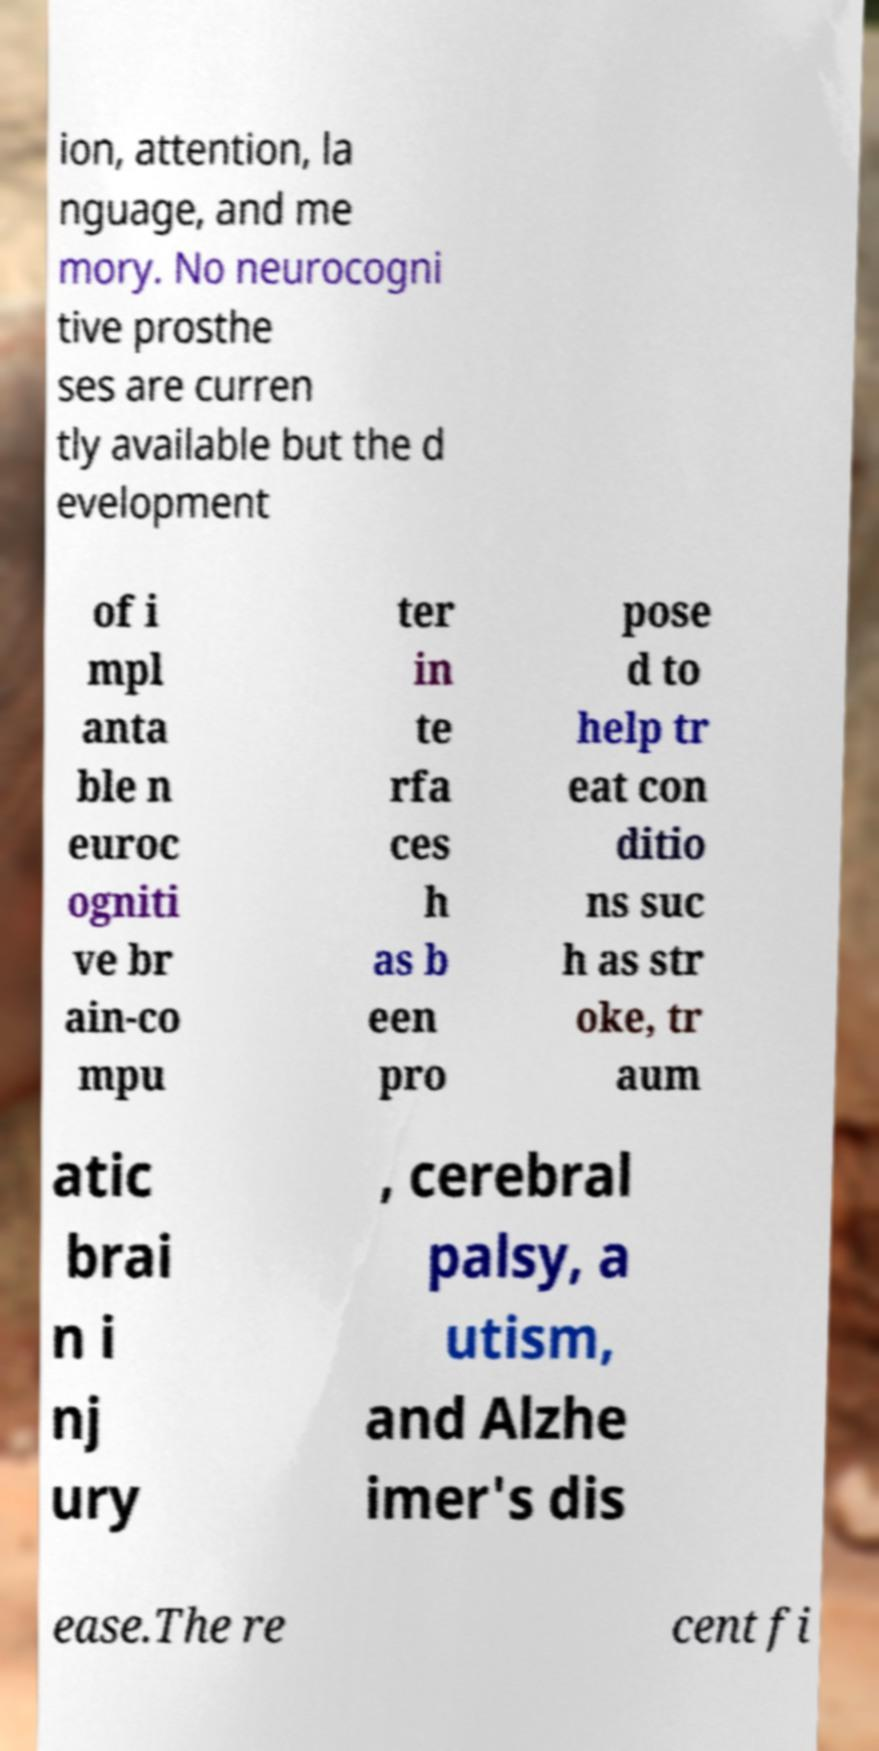Please read and relay the text visible in this image. What does it say? ion, attention, la nguage, and me mory. No neurocogni tive prosthe ses are curren tly available but the d evelopment of i mpl anta ble n euroc ogniti ve br ain-co mpu ter in te rfa ces h as b een pro pose d to help tr eat con ditio ns suc h as str oke, tr aum atic brai n i nj ury , cerebral palsy, a utism, and Alzhe imer's dis ease.The re cent fi 